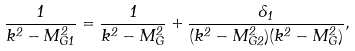Convert formula to latex. <formula><loc_0><loc_0><loc_500><loc_500>\frac { 1 } { k ^ { 2 } - M _ { G 1 } ^ { 2 } } = \frac { 1 } { k ^ { 2 } - M _ { G } ^ { 2 } } + \frac { \delta _ { 1 } } { ( k ^ { 2 } - M _ { G 2 } ^ { 2 } ) ( k ^ { 2 } - M _ { G } ^ { 2 } ) } ,</formula> 